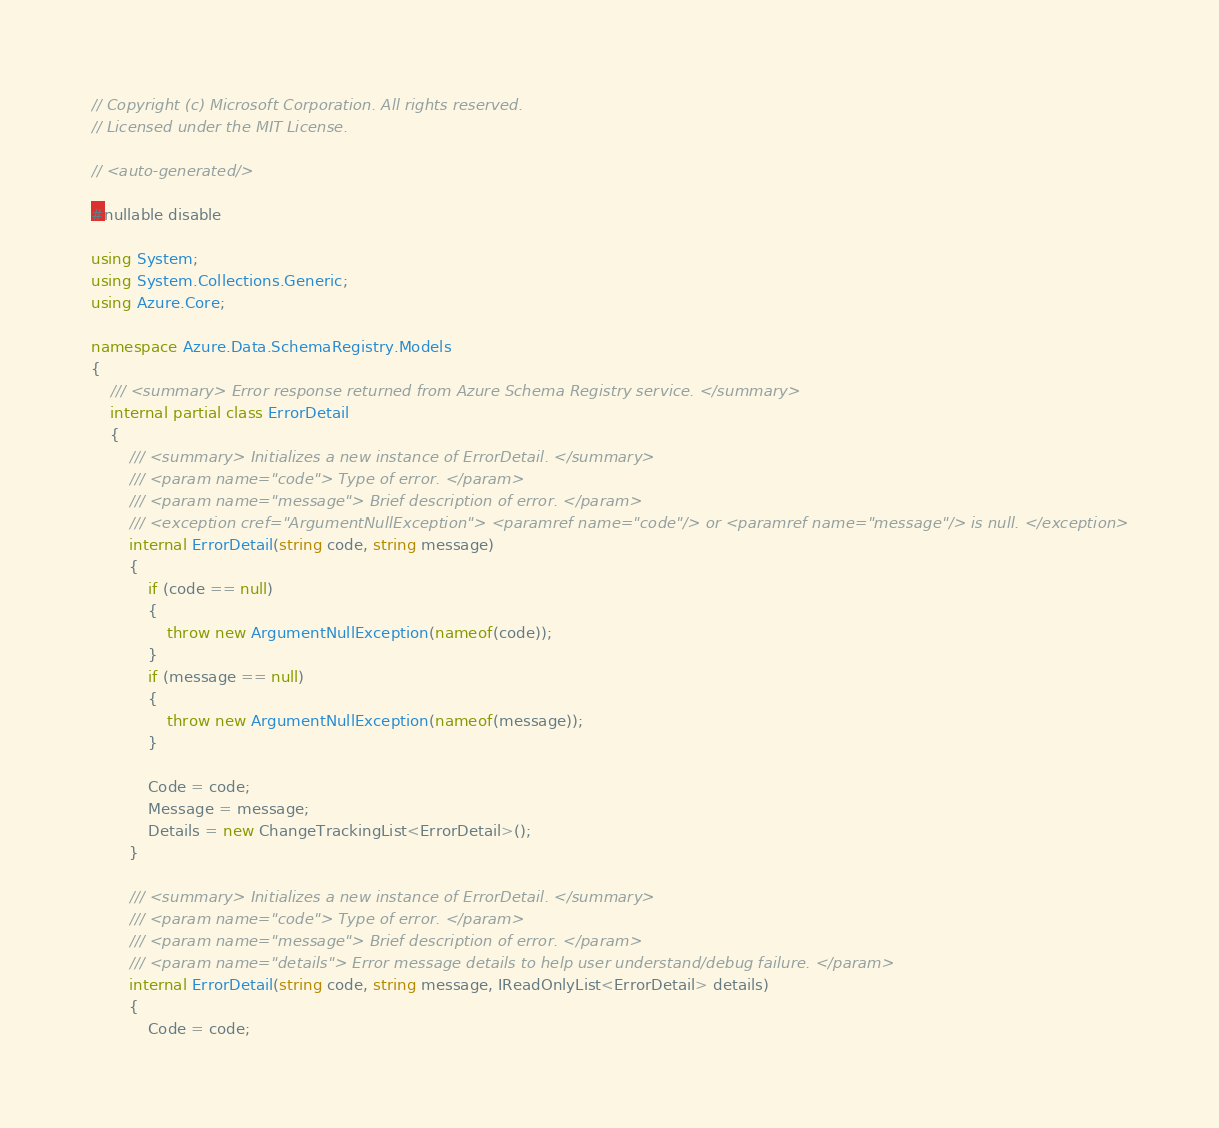Convert code to text. <code><loc_0><loc_0><loc_500><loc_500><_C#_>// Copyright (c) Microsoft Corporation. All rights reserved.
// Licensed under the MIT License.

// <auto-generated/>

#nullable disable

using System;
using System.Collections.Generic;
using Azure.Core;

namespace Azure.Data.SchemaRegistry.Models
{
    /// <summary> Error response returned from Azure Schema Registry service. </summary>
    internal partial class ErrorDetail
    {
        /// <summary> Initializes a new instance of ErrorDetail. </summary>
        /// <param name="code"> Type of error. </param>
        /// <param name="message"> Brief description of error. </param>
        /// <exception cref="ArgumentNullException"> <paramref name="code"/> or <paramref name="message"/> is null. </exception>
        internal ErrorDetail(string code, string message)
        {
            if (code == null)
            {
                throw new ArgumentNullException(nameof(code));
            }
            if (message == null)
            {
                throw new ArgumentNullException(nameof(message));
            }

            Code = code;
            Message = message;
            Details = new ChangeTrackingList<ErrorDetail>();
        }

        /// <summary> Initializes a new instance of ErrorDetail. </summary>
        /// <param name="code"> Type of error. </param>
        /// <param name="message"> Brief description of error. </param>
        /// <param name="details"> Error message details to help user understand/debug failure. </param>
        internal ErrorDetail(string code, string message, IReadOnlyList<ErrorDetail> details)
        {
            Code = code;</code> 